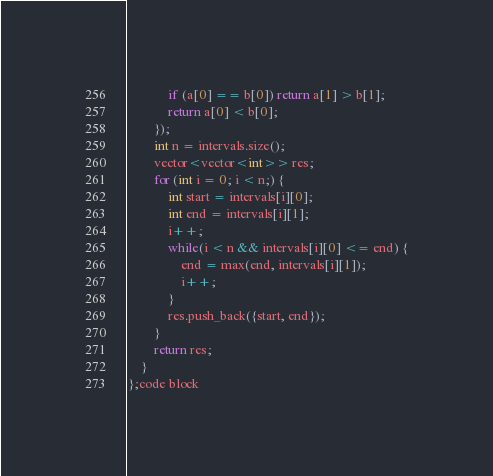Convert code to text. <code><loc_0><loc_0><loc_500><loc_500><_C++_>            if (a[0] == b[0]) return a[1] > b[1];
            return a[0] < b[0];
        });
        int n = intervals.size();
        vector<vector<int>> res;
        for (int i = 0; i < n;) {
            int start = intervals[i][0];
            int end = intervals[i][1];
            i++;
            while(i < n && intervals[i][0] <= end) {
                end = max(end, intervals[i][1]);
                i++;
            }
            res.push_back({start, end});
        }
        return res;
    }
};code block

</code> 